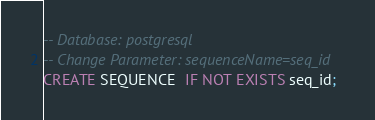Convert code to text. <code><loc_0><loc_0><loc_500><loc_500><_SQL_>-- Database: postgresql
-- Change Parameter: sequenceName=seq_id
CREATE SEQUENCE  IF NOT EXISTS seq_id;
</code> 